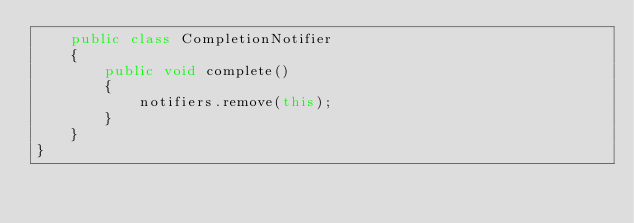Convert code to text. <code><loc_0><loc_0><loc_500><loc_500><_Java_>    public class CompletionNotifier
    {
        public void complete()
        {
            notifiers.remove(this);
        }
    }
}
</code> 